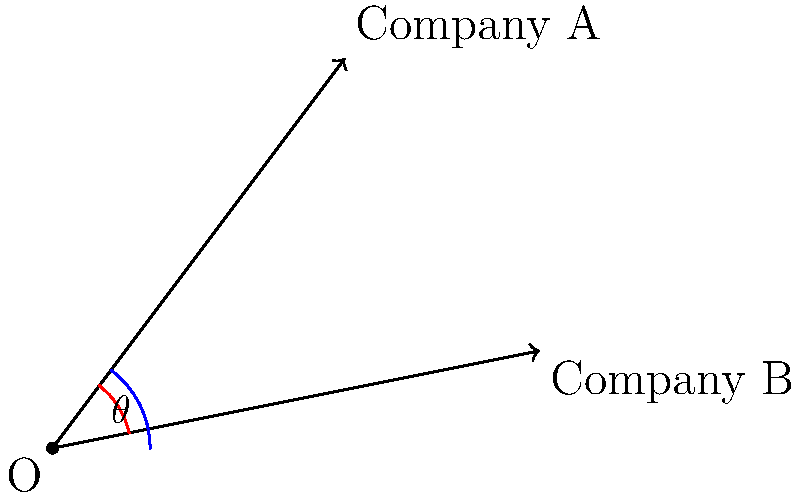In the gaming industry, two companies' logos are represented as vectors from the origin. Company A's logo is represented by the vector (3, 4), while Company B's logo is represented by the vector (5, 1). As a strategic account manager, you need to determine the angle between these two logos for a partnership presentation. Calculate the angle $\theta$ (in degrees) between these two vectors. To find the angle between two vectors, we can use the dot product formula:

$$\cos \theta = \frac{\vec{a} \cdot \vec{b}}{|\vec{a}||\vec{b}|}$$

Step 1: Calculate the dot product of the two vectors.
$\vec{a} \cdot \vec{b} = (3 \times 5) + (4 \times 1) = 15 + 4 = 19$

Step 2: Calculate the magnitudes of the vectors.
$|\vec{a}| = \sqrt{3^2 + 4^2} = \sqrt{25} = 5$
$|\vec{b}| = \sqrt{5^2 + 1^2} = \sqrt{26}$

Step 3: Substitute these values into the formula.
$$\cos \theta = \frac{19}{5\sqrt{26}}$$

Step 4: Take the inverse cosine (arccos) of both sides.
$$\theta = \arccos\left(\frac{19}{5\sqrt{26}}\right)$$

Step 5: Calculate the result (using a calculator).
$$\theta \approx 44.42°$$
Answer: $44.42°$ 